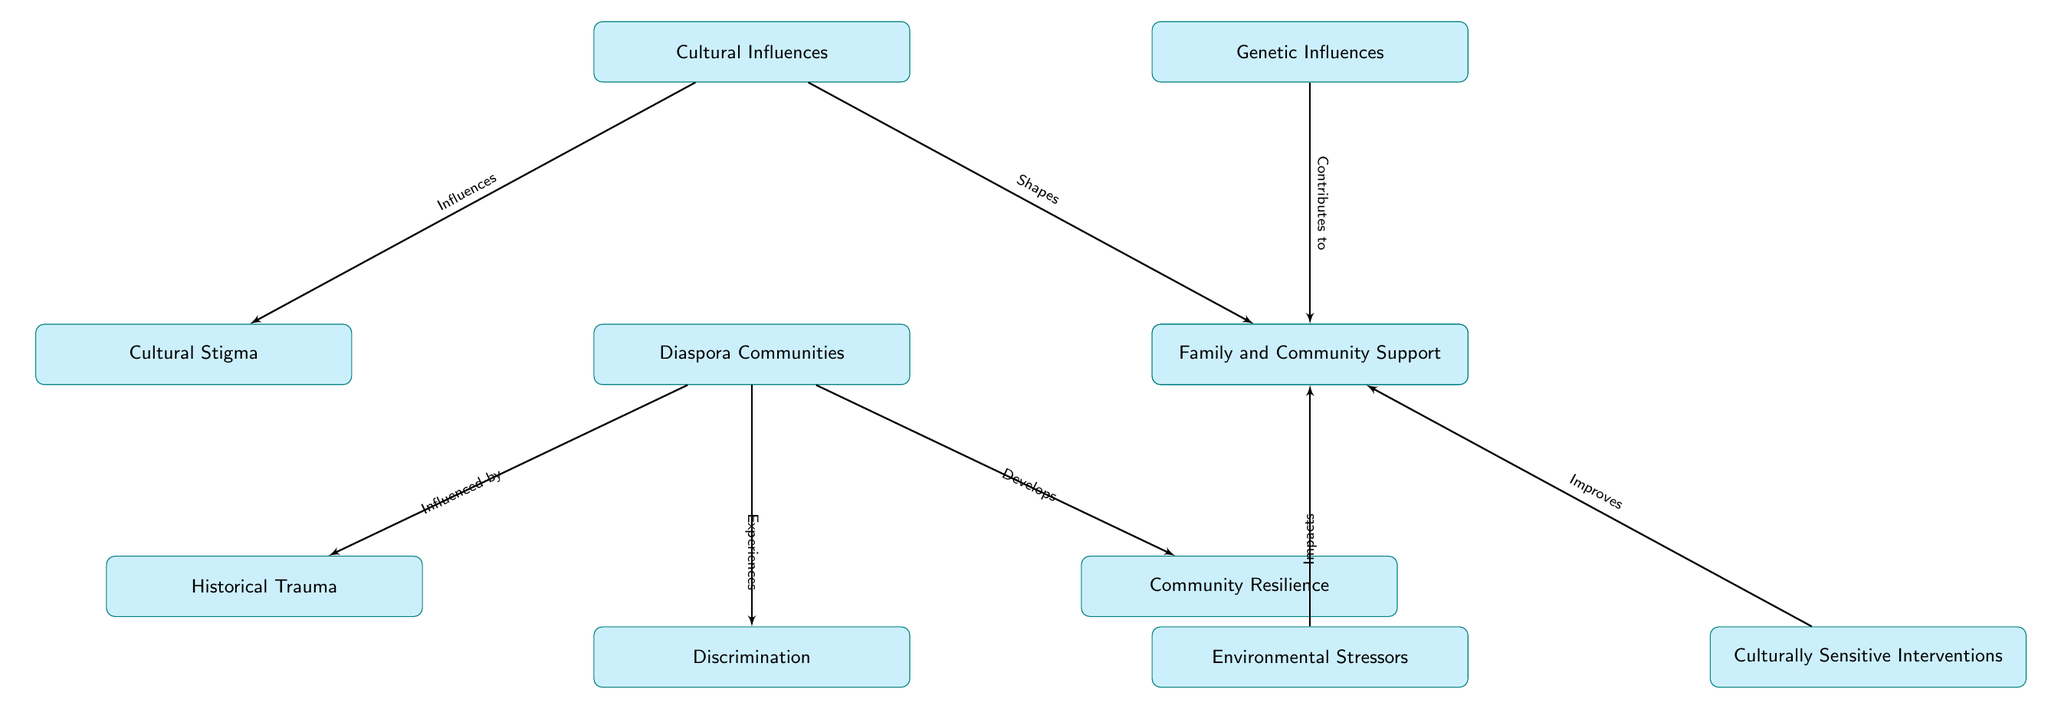What is located directly above the Mental Health node? The node directly above the Mental Health node in the diagram is the Diaspora Communities node. This is observable by tracing the vertical direction in the layout, showing a clear hierarchy where Diaspora is positioned directly above Mental Health.
Answer: Diaspora Communities How many nodes are connected to the Diaspora node? There are five nodes directly connected to the Diaspora node based on the layout. These connections are to Stigma, Support, Trauma, Discrimination, and Resilience, which can be counted from the diagram.
Answer: 5 What type of influence is represented by the arrow between Culture and Stigma? The arrow between Culture and Stigma indicates that there is an influence relationship, specifically labeled as "Influences." This relationship can be read off the diagram where the connection labels are stated clearly.
Answer: Influences Which two nodes are directly related to Environmental Stressors? The two nodes directly related to Environmental Stressors are Mental Health and Culturally Sensitive Interventions. This can be identified by following the edges that connect to Environment, indicating these two specific links.
Answer: Mental Health and Culturally Sensitive Interventions What does the arrow between Genetics and Mental Health indicate? The arrow between Genetics and Mental Health signifies a contribution relationship, described in the diagram as "Contributes to." This connection emphasizes the role genetics plays in affecting mental health disorders, according to the label placed on the connecting edge.
Answer: Contributes to How does Community Resilience develop in the context of the Diaspora? Community Resilience develops as a response to experiences within the Diaspora, as indicated by the edge that flows from Diaspora to Resilience, labeled as "Develops." This points to the idea that experiences unique to the Diaspora foster resilience among community members.
Answer: Develops What is the relationship labeled between Family and Community Support and Cultural Influences? The relationship labeled between Family and Community Support and Cultural Influences is "Shapes." This indicates that cultural influences mold the ways in which family and community support are structured or manifested, based on the connection seen in the diagram.
Answer: Shapes Which element is an environmental factor impacting Mental Health? The element identified as an environmental factor impacting Mental Health is Environmental Stressors. This is explicitly shown in the diagram where the Environmental Stressors node connects directly to the Mental Health node indicating a direct impact relationship.
Answer: Environmental Stressors 